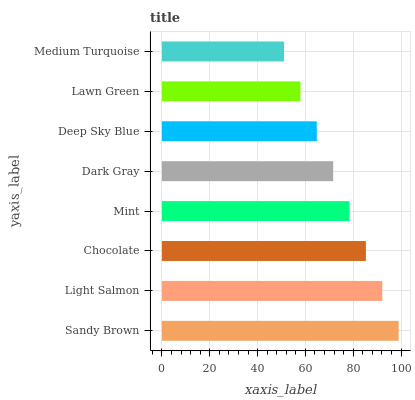Is Medium Turquoise the minimum?
Answer yes or no. Yes. Is Sandy Brown the maximum?
Answer yes or no. Yes. Is Light Salmon the minimum?
Answer yes or no. No. Is Light Salmon the maximum?
Answer yes or no. No. Is Sandy Brown greater than Light Salmon?
Answer yes or no. Yes. Is Light Salmon less than Sandy Brown?
Answer yes or no. Yes. Is Light Salmon greater than Sandy Brown?
Answer yes or no. No. Is Sandy Brown less than Light Salmon?
Answer yes or no. No. Is Mint the high median?
Answer yes or no. Yes. Is Dark Gray the low median?
Answer yes or no. Yes. Is Lawn Green the high median?
Answer yes or no. No. Is Medium Turquoise the low median?
Answer yes or no. No. 